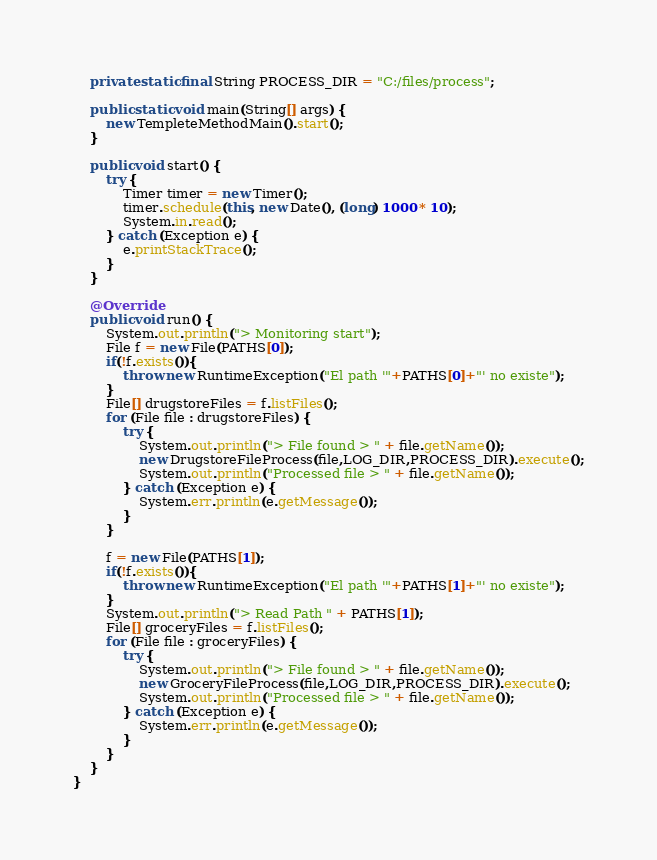Convert code to text. <code><loc_0><loc_0><loc_500><loc_500><_Java_>    private static final String PROCESS_DIR = "C:/files/process";

    public static void main(String[] args) {
        new TempleteMethodMain().start();
    }

    public void start() {
        try {
            Timer timer = new Timer();
            timer.schedule(this, new Date(), (long) 1000 * 10);
            System.in.read();
        } catch (Exception e) {
            e.printStackTrace();
        }
    }

    @Override
    public void run() {
        System.out.println("> Monitoring start");
        File f = new File(PATHS[0]);
        if(!f.exists()){
            throw new RuntimeException("El path '"+PATHS[0]+"' no existe");
        }
        File[] drugstoreFiles = f.listFiles();
        for (File file : drugstoreFiles) {
            try {
                System.out.println("> File found > " + file.getName());
                new DrugstoreFileProcess(file,LOG_DIR,PROCESS_DIR).execute();
                System.out.println("Processed file > " + file.getName());
            } catch (Exception e) {
                System.err.println(e.getMessage());
            }
        }
        
        f = new File(PATHS[1]);
        if(!f.exists()){
            throw new RuntimeException("El path '"+PATHS[1]+"' no existe");
        }
        System.out.println("> Read Path " + PATHS[1]);
        File[] groceryFiles = f.listFiles();
        for (File file : groceryFiles) {
            try {
                System.out.println("> File found > " + file.getName());
                new GroceryFileProcess(file,LOG_DIR,PROCESS_DIR).execute();
                System.out.println("Processed file > " + file.getName());
            } catch (Exception e) {
                System.err.println(e.getMessage());
            }
        }
    }
}</code> 